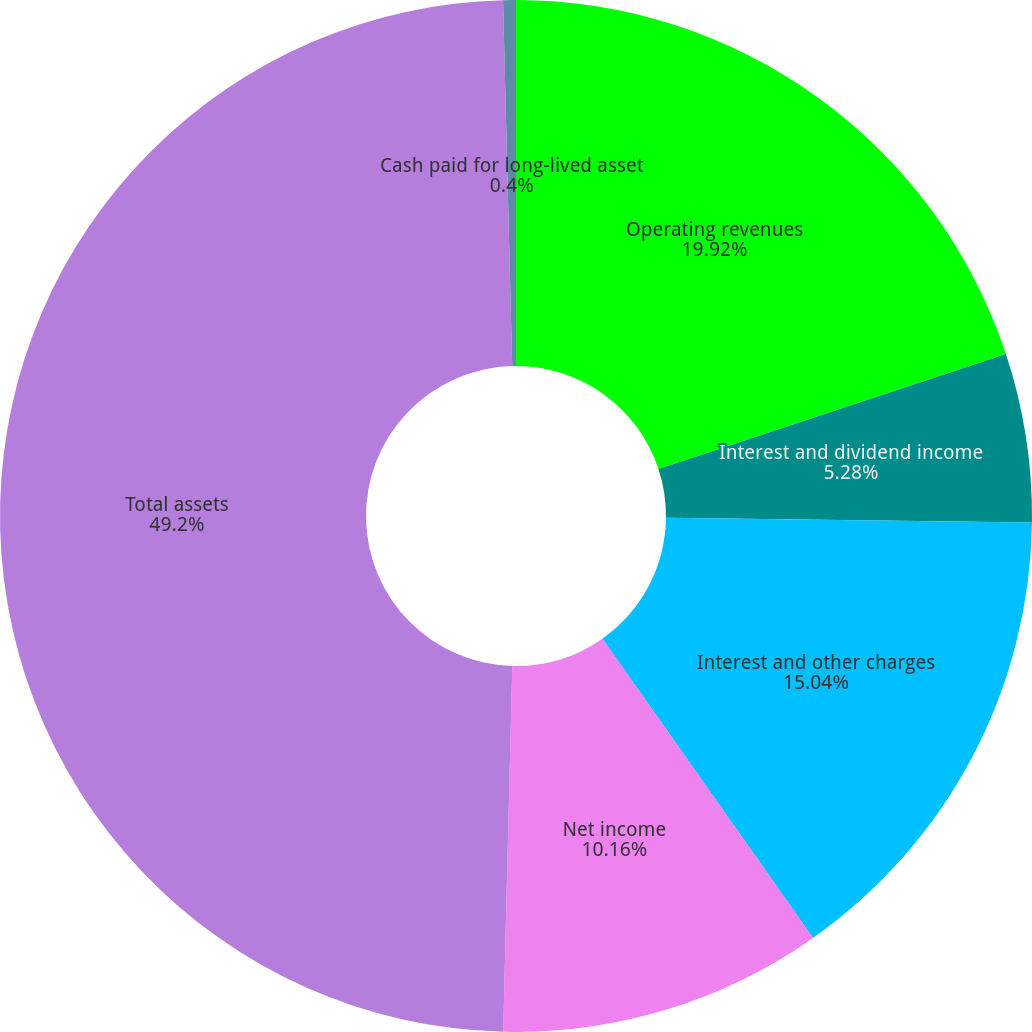<chart> <loc_0><loc_0><loc_500><loc_500><pie_chart><fcel>Operating revenues<fcel>Interest and dividend income<fcel>Interest and other charges<fcel>Net income<fcel>Total assets<fcel>Cash paid for long-lived asset<nl><fcel>19.92%<fcel>5.28%<fcel>15.04%<fcel>10.16%<fcel>49.21%<fcel>0.4%<nl></chart> 